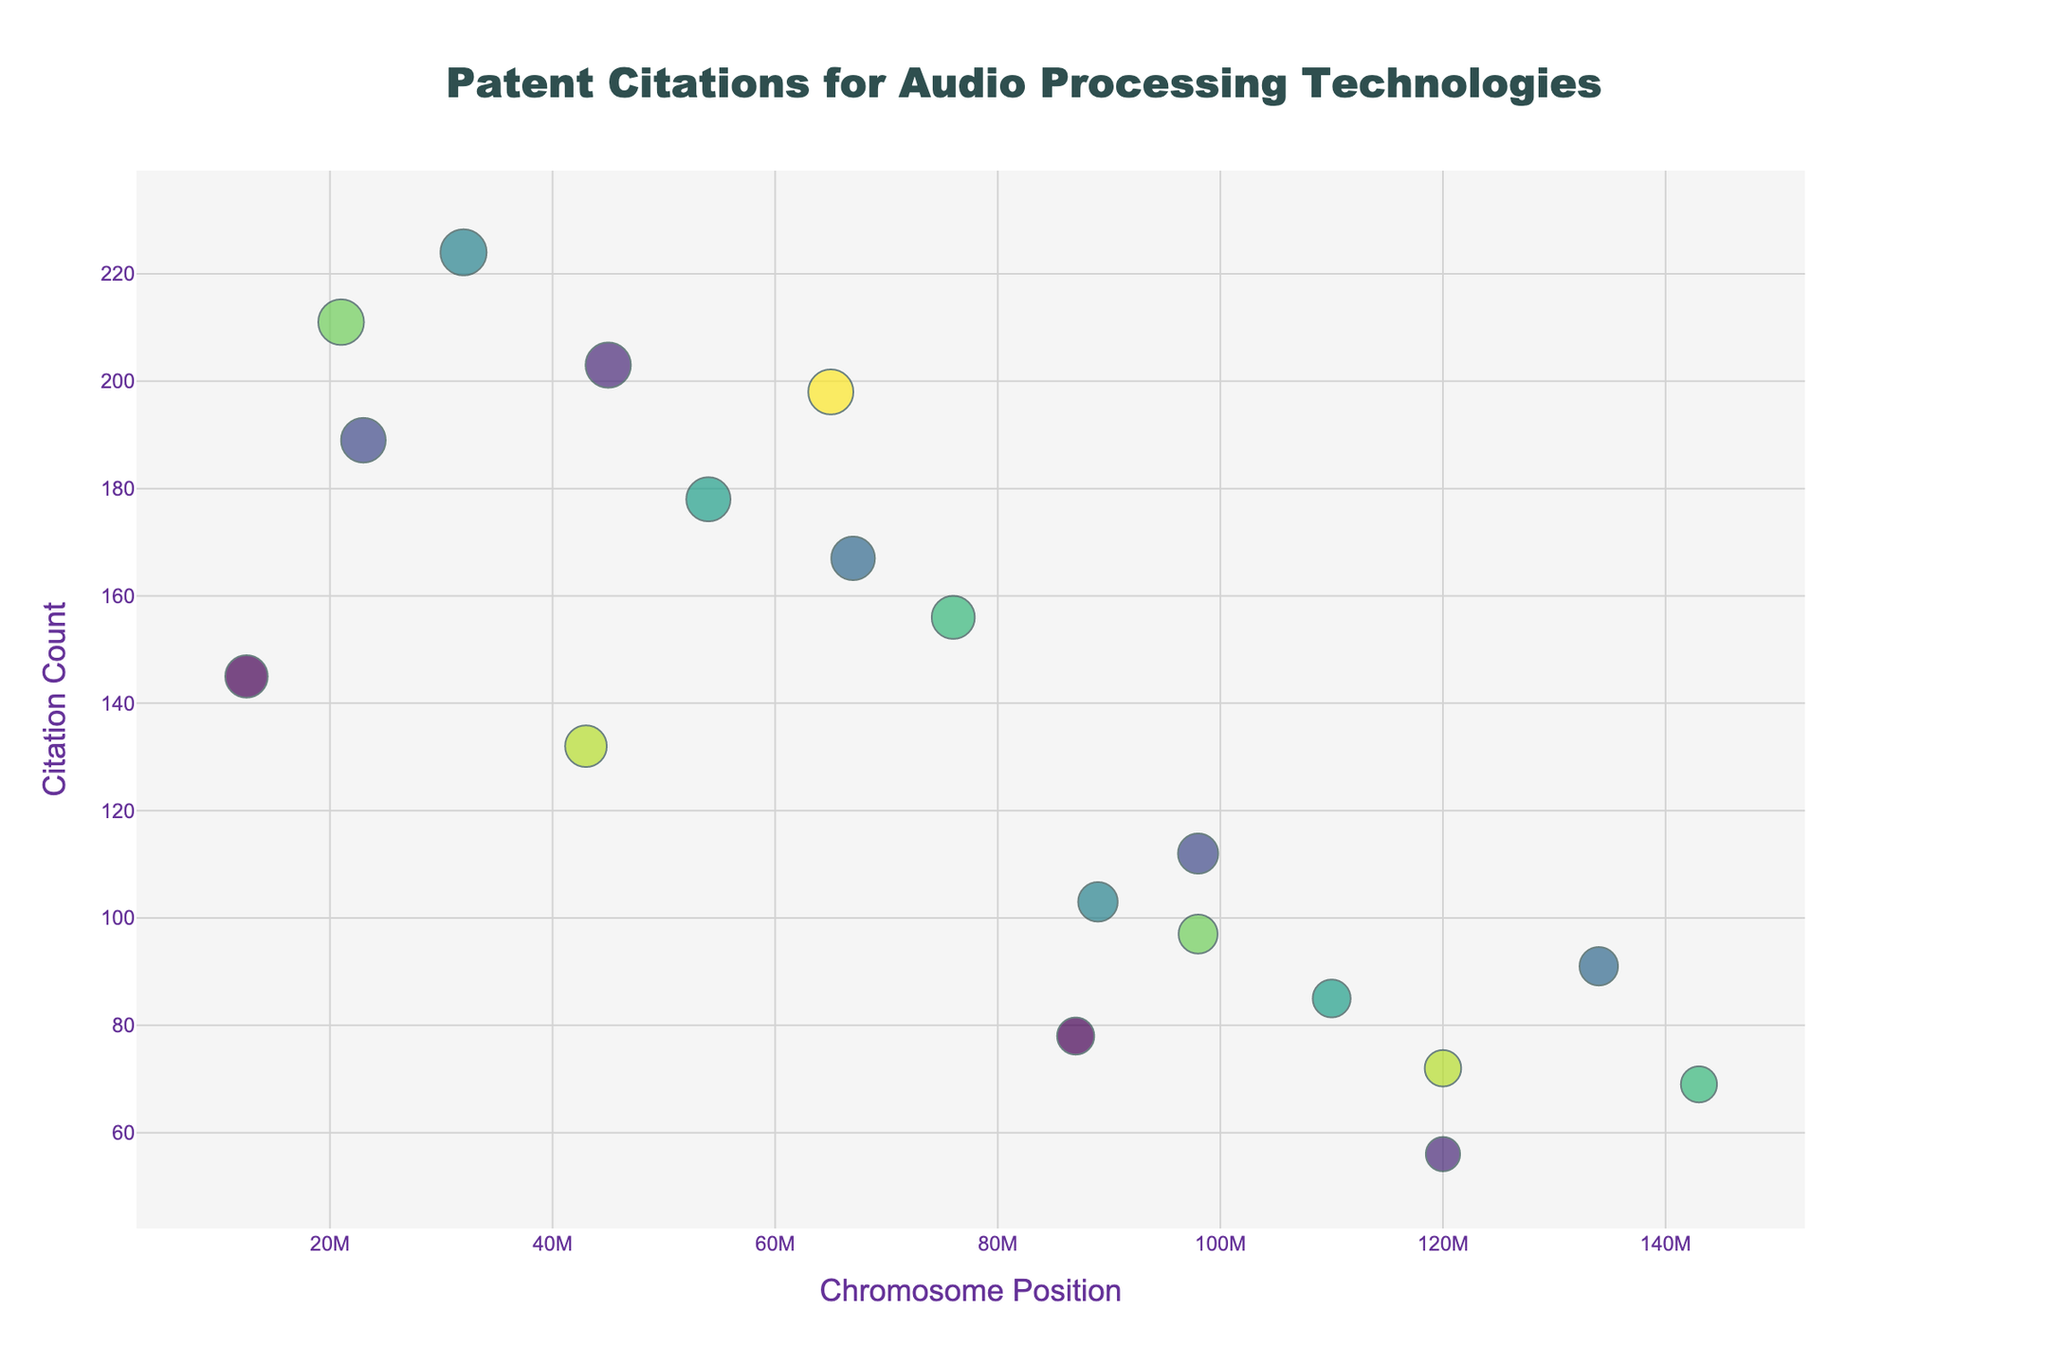What's the title of the figure? The title of a figure is typically placed at the top. In this figure, it states "Patent Citations for Audio Processing Technologies."
Answer: Patent Citations for Audio Processing Technologies Which technology has the highest citation count? By examining the vertical axis with the highest y-value, you can identify the technology with the highest citation count. Here, it corresponds to the data point with the y-value of 224, which is "Auro-3D."
Answer: Auro-3D What is the citation count for Dolby Pro Logic IIx? Find the label "Dolby Pro Logic IIx" in the hover text. The citation count next to it shows it is 145.
Answer: 145 How many technologies have a citation count greater than 150? Count the number of data points on the plot above the y-axis value of 150. Visual observation shows there are 6 such points.
Answer: 6 Which technology on chromosome 6 has the highest citation count? Look at the data points labeled with "6" for the chromosome and find the highest y-value among them. The highest y-value is 178, which corresponds to "Fraunhofer Symphoria."
Answer: Fraunhofer Symphoria What is the average citation count of the technologies on chromosome 3? Identify the citation counts for chromosome 3: 189 and 112. Sum these values (189 + 112 = 301) and divide by 2 to get the average (301/2 = 150.5).
Answer: 150.5 Which technology has the citation count closest to 100? Check the points around y-axis value 100. Look for the closest point, which here is "QSound Labs QMSS" with a citation count of 103.
Answer: QSound Labs QMSS Compare the citation counts between Yamaha Cinema DSP and SRS Circle Surround. Which is higher? Find the y-values next to "Yamaha Cinema DSP" (56) and "SRS Circle Surround" (91). SRS Circle Surround has a higher citation count.
Answer: SRS Circle Surround What is the chromosome position for Dolby Atmos Upmixer? Hover over the data points to find the position for "Dolby Atmos Upmixer," which shows it is at position 21000000 on its chromosome.
Answer: 21000000 Which data point has the largest marker size? Larger marker sizes correspond to higher citation counts due to the log scaling applied. The highest citation count (224) defines the largest marker size, which belongs to "Auro-3D."
Answer: Auro-3D 